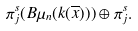<formula> <loc_0><loc_0><loc_500><loc_500>\pi _ { j } ^ { s } ( B \mu _ { n } ( k ( \overline { x } ) ) ) \oplus \pi _ { j } ^ { s } .</formula> 